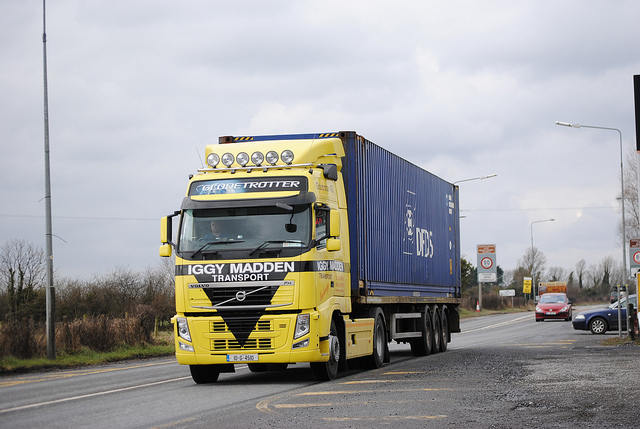Please transcribe the text in this image. GEODETROTTER IGGY MADDEN TRANSPORT DEDS 